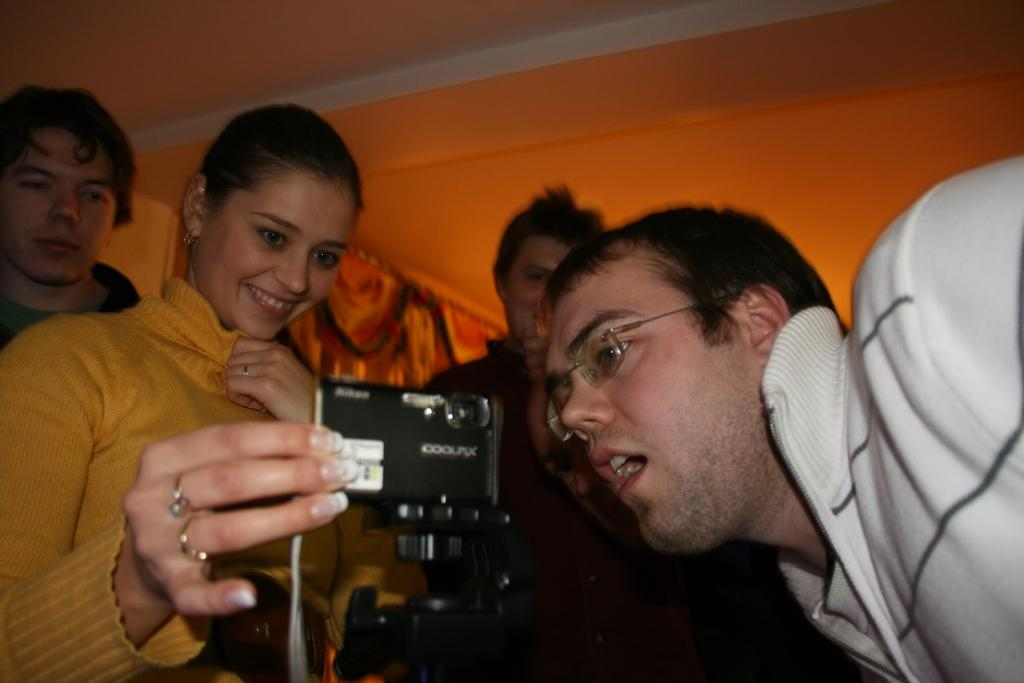How many people are in the image? There are five persons in the image. What is one person doing in the image? One person is holding a camera. What can be seen in the background of the image? There is a curtain in the background of the image. What type of feeling can be seen on the cent in the image? There is no cent present in the image, and therefore no feeling can be observed on it. 